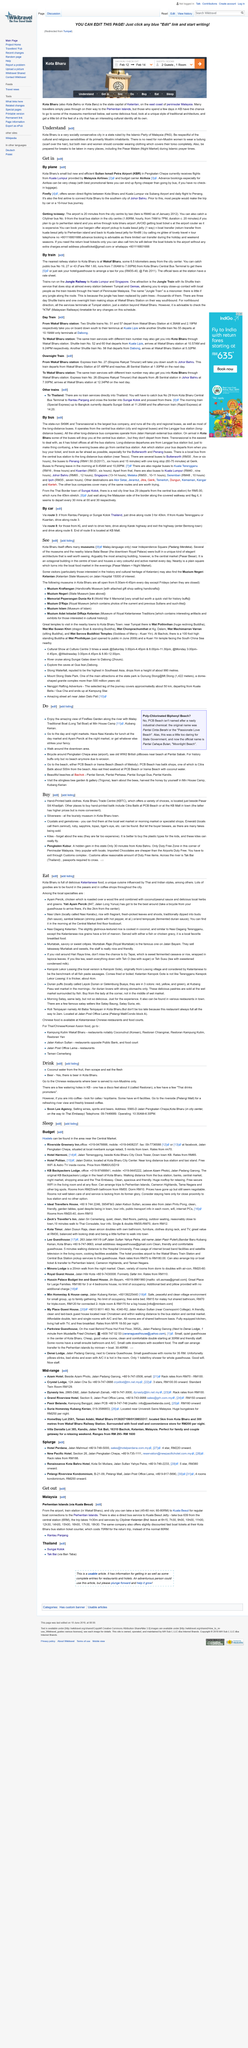Mention a couple of crucial points in this snapshot. It is possible to travel to Kota Bharu with Malaysia Airlines and AirAsia. It is essential to show respect for the cultural and religious sensibilities of the primarily Muslim inhabitants of Kota Bharu when visiting this city. The Islamic Party of Malaysia rules Kota Bharu. 